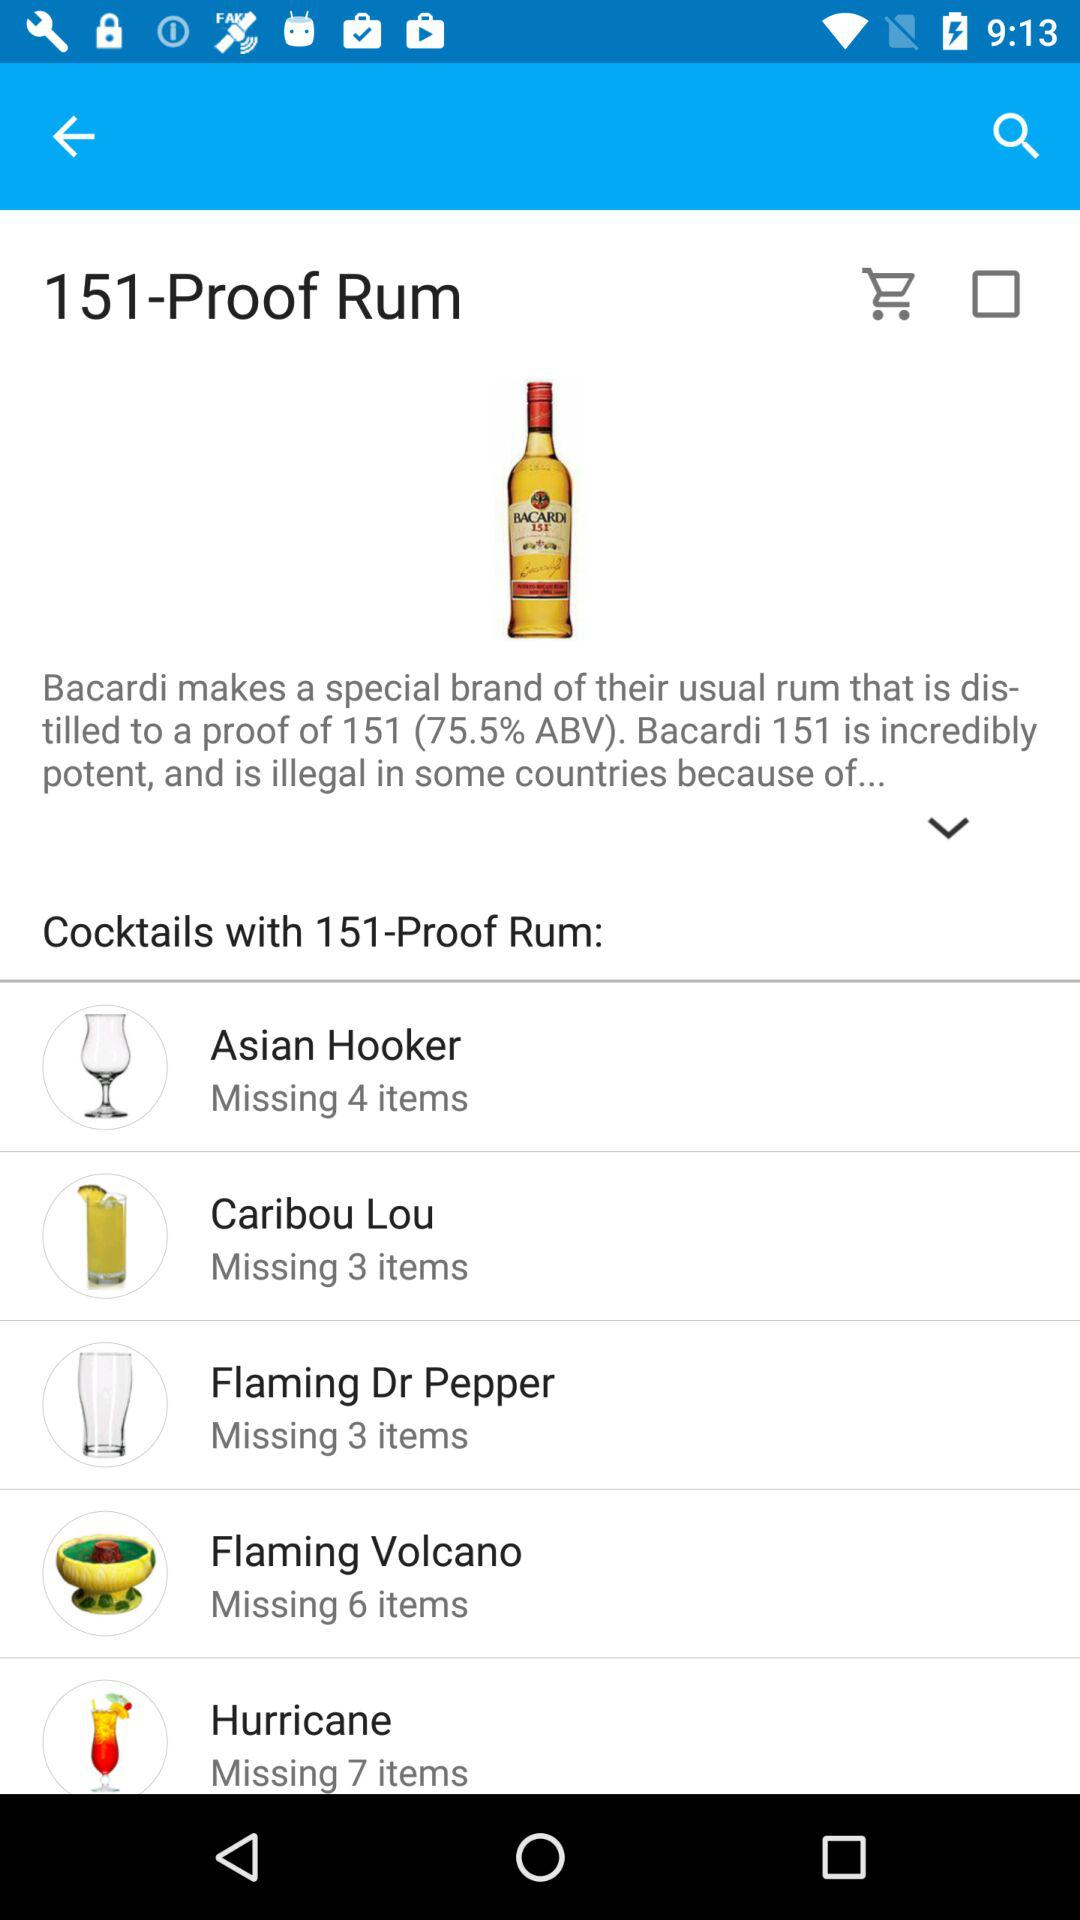What is the percentage of ABV in the Bacardi? The percentage is 75.5. 